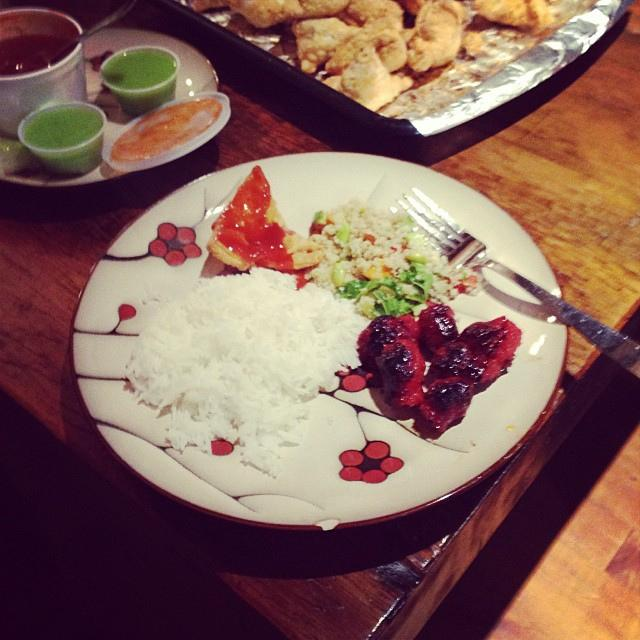How many of the ingredients on the dish were cooked by steaming them?

Choices:
A) one
B) three
C) two
D) four one 